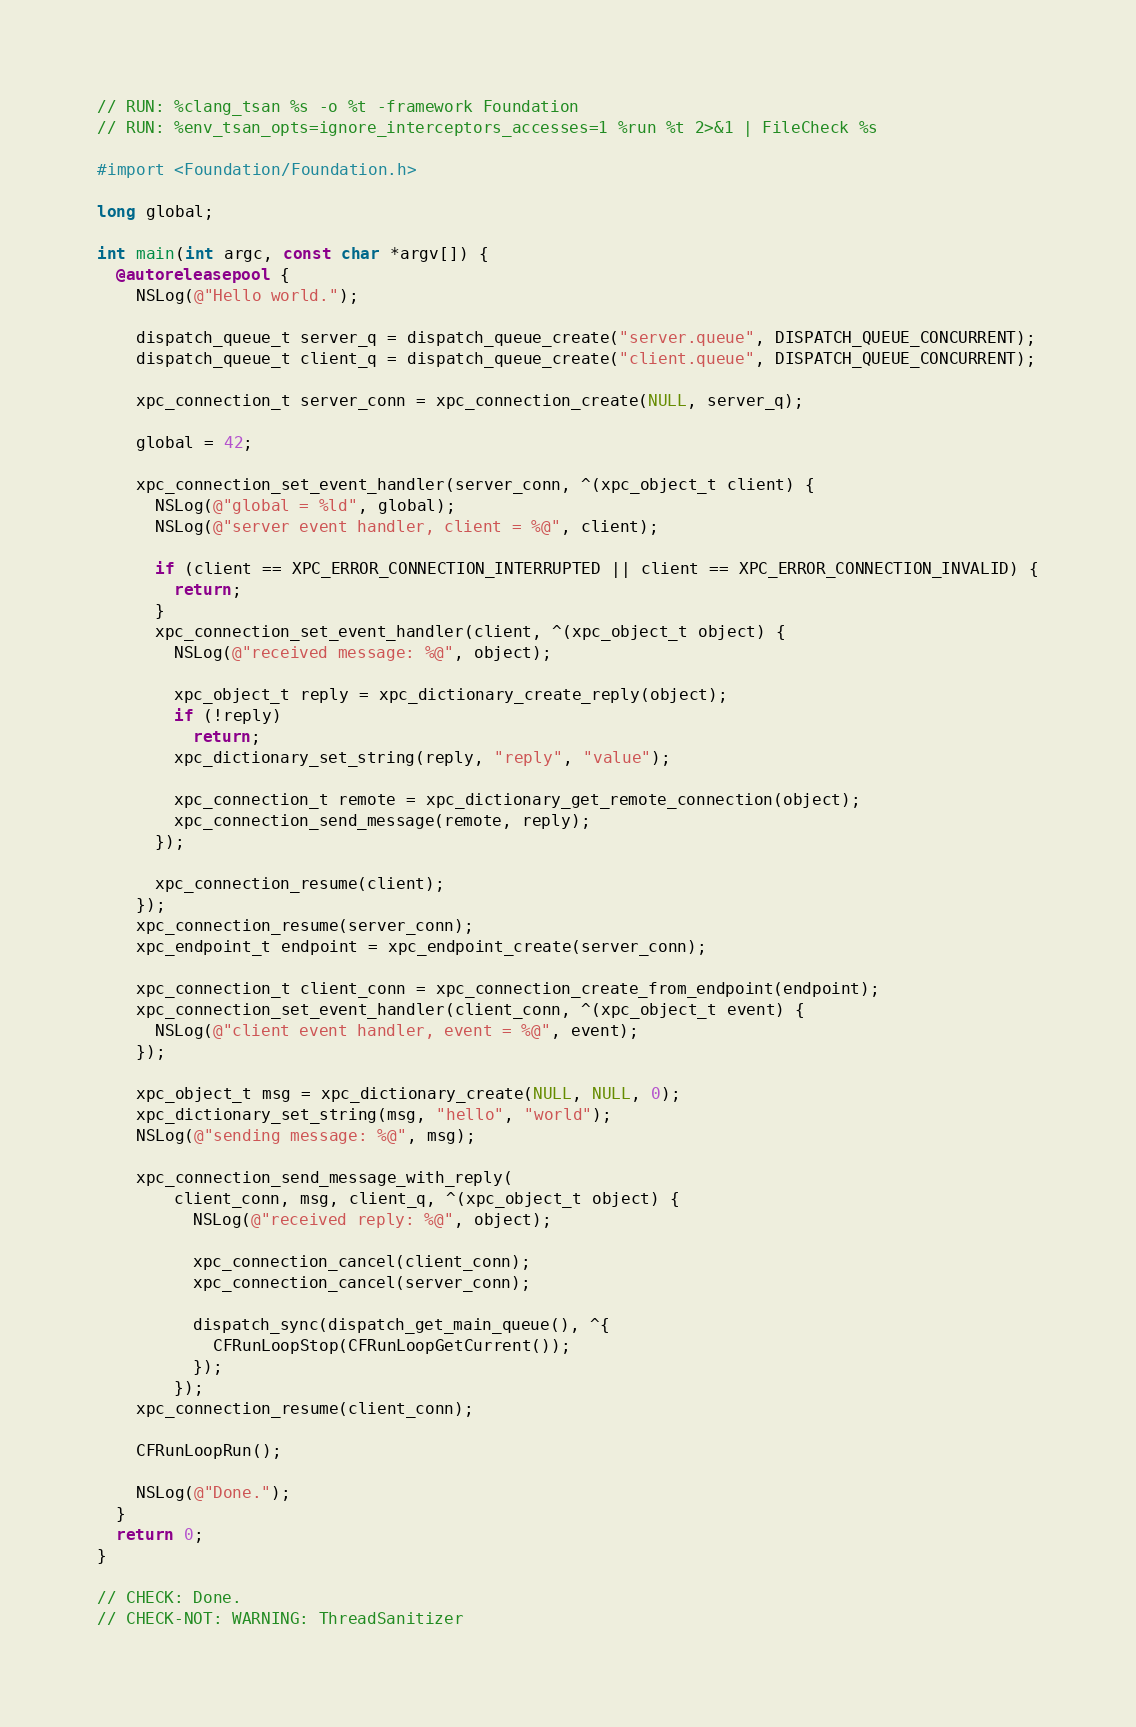<code> <loc_0><loc_0><loc_500><loc_500><_ObjectiveC_>// RUN: %clang_tsan %s -o %t -framework Foundation
// RUN: %env_tsan_opts=ignore_interceptors_accesses=1 %run %t 2>&1 | FileCheck %s

#import <Foundation/Foundation.h>

long global;

int main(int argc, const char *argv[]) {
  @autoreleasepool {
    NSLog(@"Hello world.");

    dispatch_queue_t server_q = dispatch_queue_create("server.queue", DISPATCH_QUEUE_CONCURRENT);
    dispatch_queue_t client_q = dispatch_queue_create("client.queue", DISPATCH_QUEUE_CONCURRENT);

    xpc_connection_t server_conn = xpc_connection_create(NULL, server_q);

    global = 42;

    xpc_connection_set_event_handler(server_conn, ^(xpc_object_t client) {
      NSLog(@"global = %ld", global);
      NSLog(@"server event handler, client = %@", client);

      if (client == XPC_ERROR_CONNECTION_INTERRUPTED || client == XPC_ERROR_CONNECTION_INVALID) {
        return;
      }
      xpc_connection_set_event_handler(client, ^(xpc_object_t object) {
        NSLog(@"received message: %@", object);

        xpc_object_t reply = xpc_dictionary_create_reply(object);
        if (!reply)
          return;
        xpc_dictionary_set_string(reply, "reply", "value");

        xpc_connection_t remote = xpc_dictionary_get_remote_connection(object);
        xpc_connection_send_message(remote, reply);
      });

      xpc_connection_resume(client);
    });
    xpc_connection_resume(server_conn);
    xpc_endpoint_t endpoint = xpc_endpoint_create(server_conn);

    xpc_connection_t client_conn = xpc_connection_create_from_endpoint(endpoint);
    xpc_connection_set_event_handler(client_conn, ^(xpc_object_t event) {
      NSLog(@"client event handler, event = %@", event);
    });

    xpc_object_t msg = xpc_dictionary_create(NULL, NULL, 0);
    xpc_dictionary_set_string(msg, "hello", "world");
    NSLog(@"sending message: %@", msg);

    xpc_connection_send_message_with_reply(
        client_conn, msg, client_q, ^(xpc_object_t object) {
          NSLog(@"received reply: %@", object);

          xpc_connection_cancel(client_conn);
          xpc_connection_cancel(server_conn);

          dispatch_sync(dispatch_get_main_queue(), ^{
            CFRunLoopStop(CFRunLoopGetCurrent());
          });
        });
    xpc_connection_resume(client_conn);

    CFRunLoopRun();

    NSLog(@"Done.");
  }
  return 0;
}

// CHECK: Done.
// CHECK-NOT: WARNING: ThreadSanitizer
</code> 